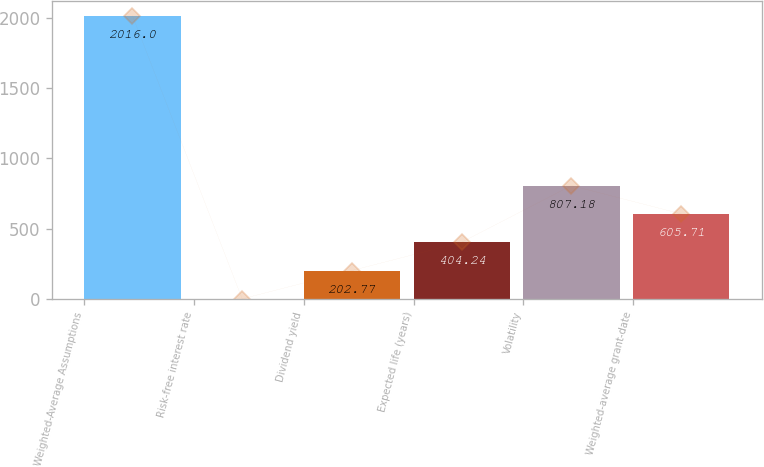Convert chart to OTSL. <chart><loc_0><loc_0><loc_500><loc_500><bar_chart><fcel>Weighted-Average Assumptions<fcel>Risk-free interest rate<fcel>Dividend yield<fcel>Expected life (years)<fcel>Volatility<fcel>Weighted-average grant-date<nl><fcel>2016<fcel>1.3<fcel>202.77<fcel>404.24<fcel>807.18<fcel>605.71<nl></chart> 